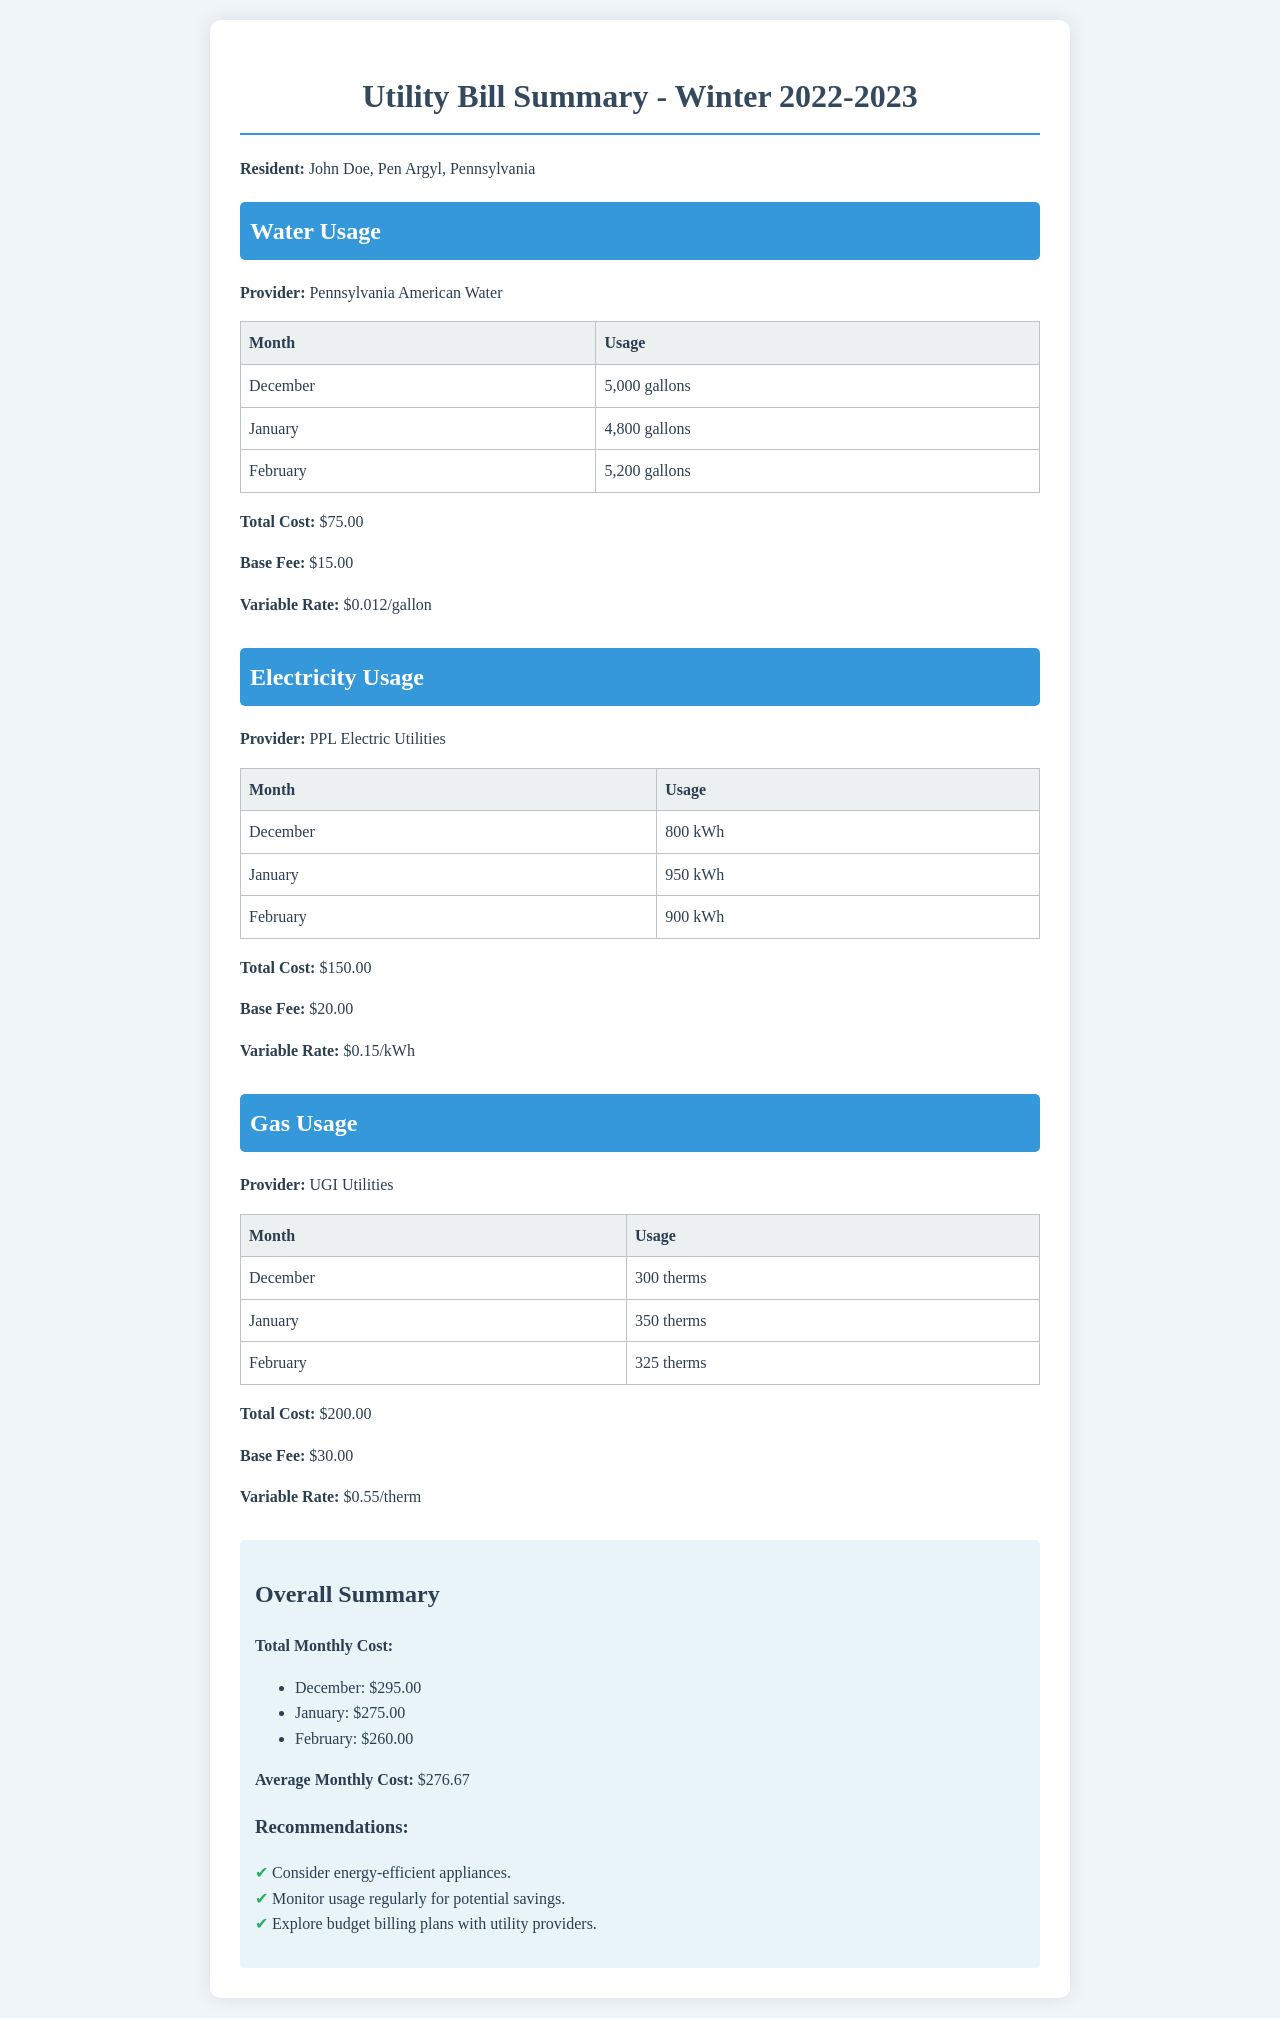What is the total cost for water? The total cost for water is clearly stated in the summary section of the document.
Answer: $75.00 How much electricity was used in January? The electricity usage for January is displayed in the table under the Electricity Usage section.
Answer: 950 kWh What is the variable rate for gas? The variable rate for gas is mentioned before the summary in the Gas Usage section.
Answer: $0.55/therm What was the average monthly cost? The average monthly cost is calculated from the total monthly costs presented in the overall summary section.
Answer: $276.67 Which month had the highest total monthly cost? The highest total monthly cost can be determined by examining the list of costs for each month in the overall summary.
Answer: December 